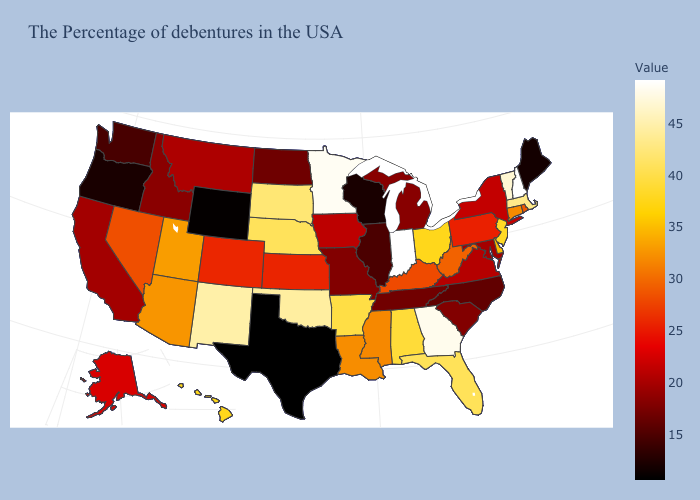Which states hav the highest value in the West?
Keep it brief. New Mexico. Among the states that border Kentucky , which have the lowest value?
Short answer required. Illinois. Which states have the lowest value in the Northeast?
Short answer required. Maine. Which states have the highest value in the USA?
Keep it brief. New Hampshire, Indiana. Which states have the lowest value in the West?
Answer briefly. Wyoming. Which states have the lowest value in the West?
Give a very brief answer. Wyoming. Which states have the lowest value in the MidWest?
Short answer required. Wisconsin. Does Texas have the lowest value in the South?
Write a very short answer. Yes. 